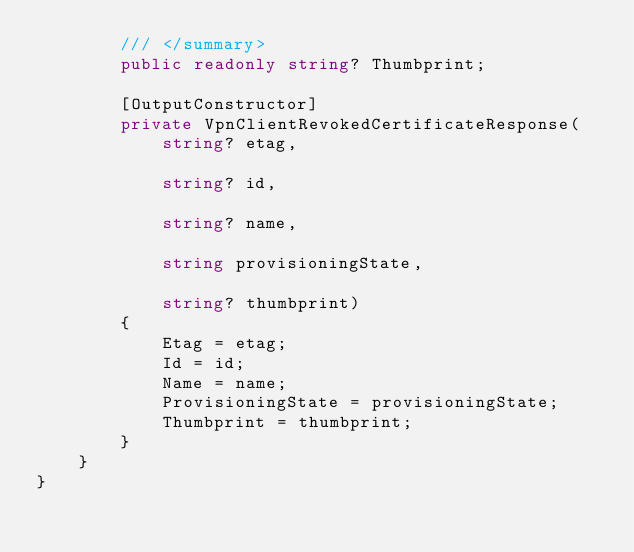Convert code to text. <code><loc_0><loc_0><loc_500><loc_500><_C#_>        /// </summary>
        public readonly string? Thumbprint;

        [OutputConstructor]
        private VpnClientRevokedCertificateResponse(
            string? etag,

            string? id,

            string? name,

            string provisioningState,

            string? thumbprint)
        {
            Etag = etag;
            Id = id;
            Name = name;
            ProvisioningState = provisioningState;
            Thumbprint = thumbprint;
        }
    }
}
</code> 